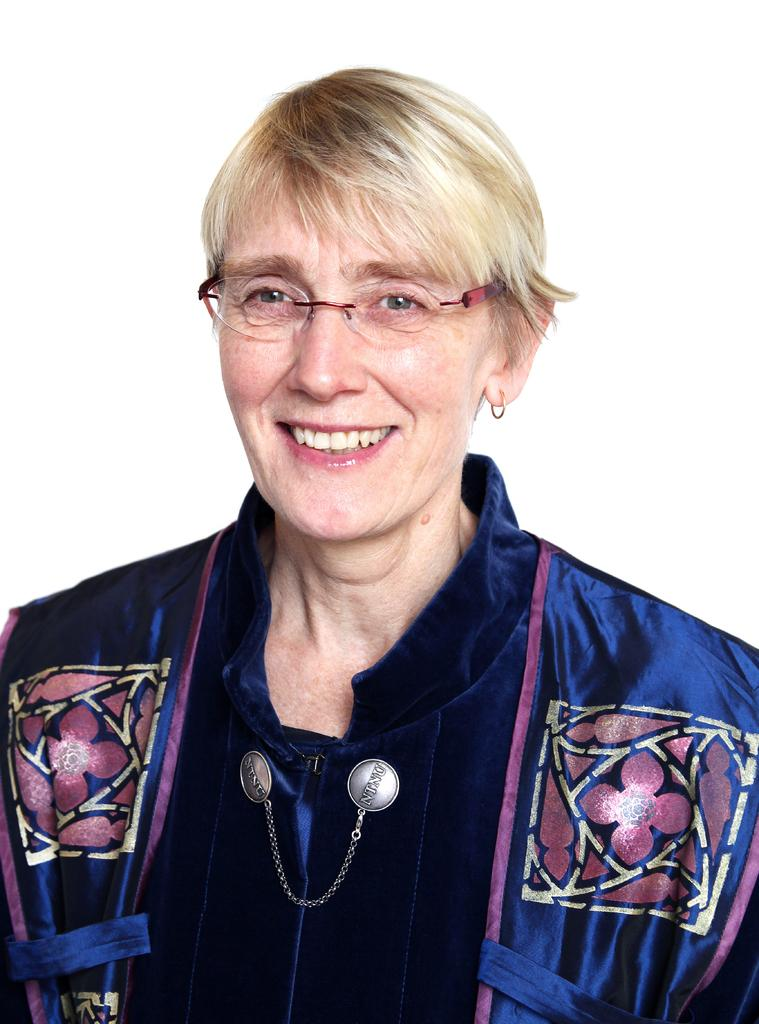Who is present in the image? There is a woman in the image. What is the woman's facial expression? The woman is smiling. What type of brush is the woman using to paint the potato in the image? There is no brush, potato, or painting activity present in the image. 